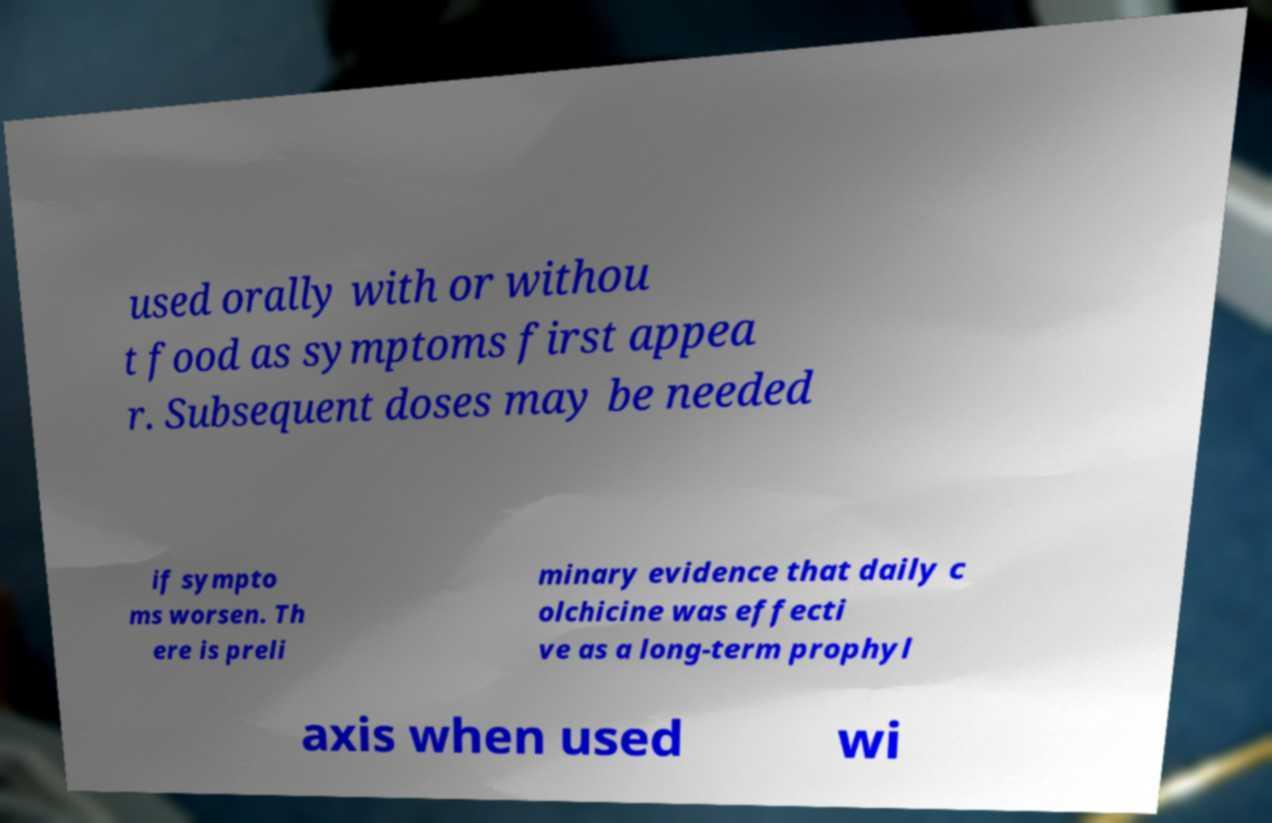Could you assist in decoding the text presented in this image and type it out clearly? used orally with or withou t food as symptoms first appea r. Subsequent doses may be needed if sympto ms worsen. Th ere is preli minary evidence that daily c olchicine was effecti ve as a long-term prophyl axis when used wi 